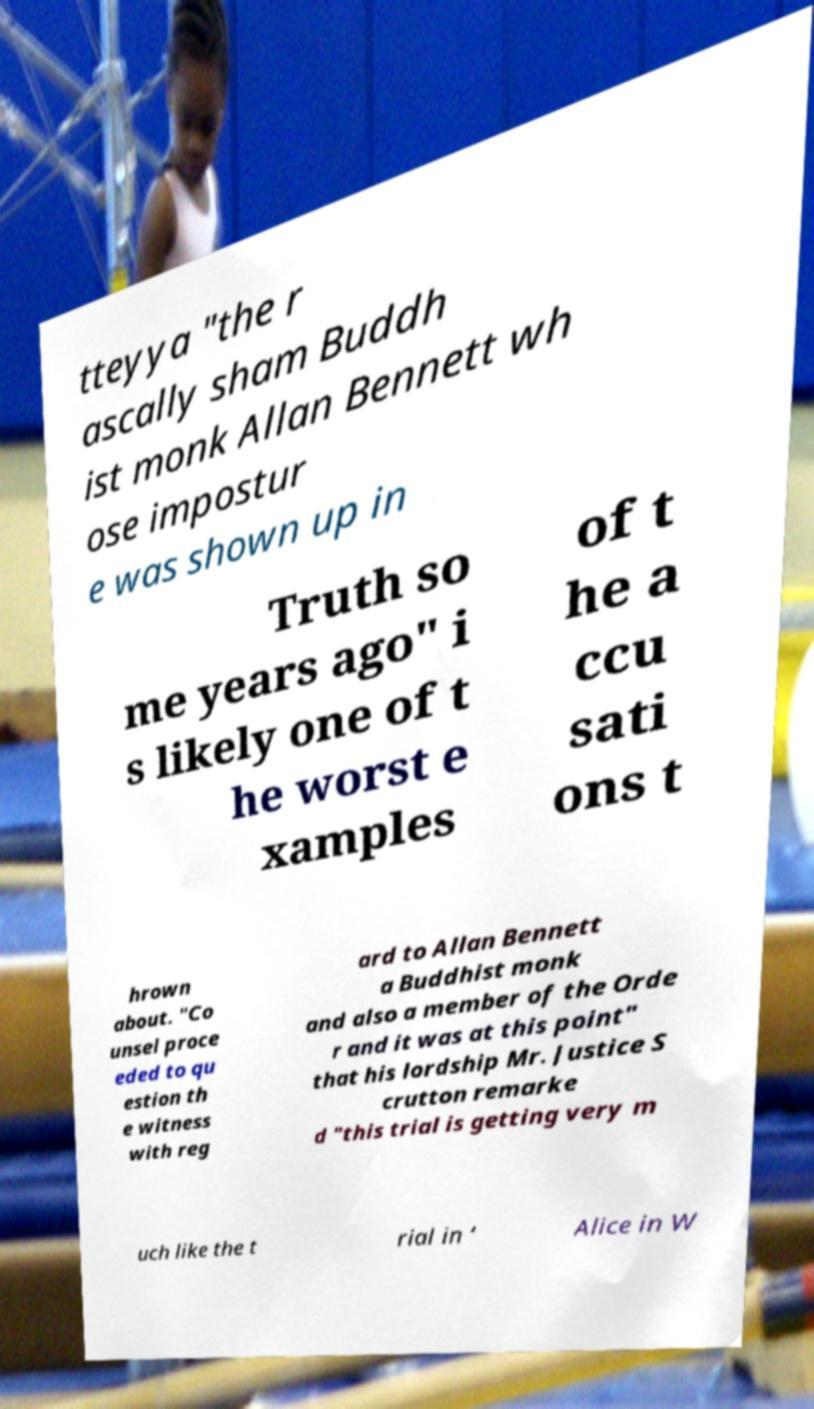For documentation purposes, I need the text within this image transcribed. Could you provide that? tteyya "the r ascally sham Buddh ist monk Allan Bennett wh ose impostur e was shown up in Truth so me years ago" i s likely one of t he worst e xamples of t he a ccu sati ons t hrown about. "Co unsel proce eded to qu estion th e witness with reg ard to Allan Bennett a Buddhist monk and also a member of the Orde r and it was at this point" that his lordship Mr. Justice S crutton remarke d "this trial is getting very m uch like the t rial in ‘ Alice in W 